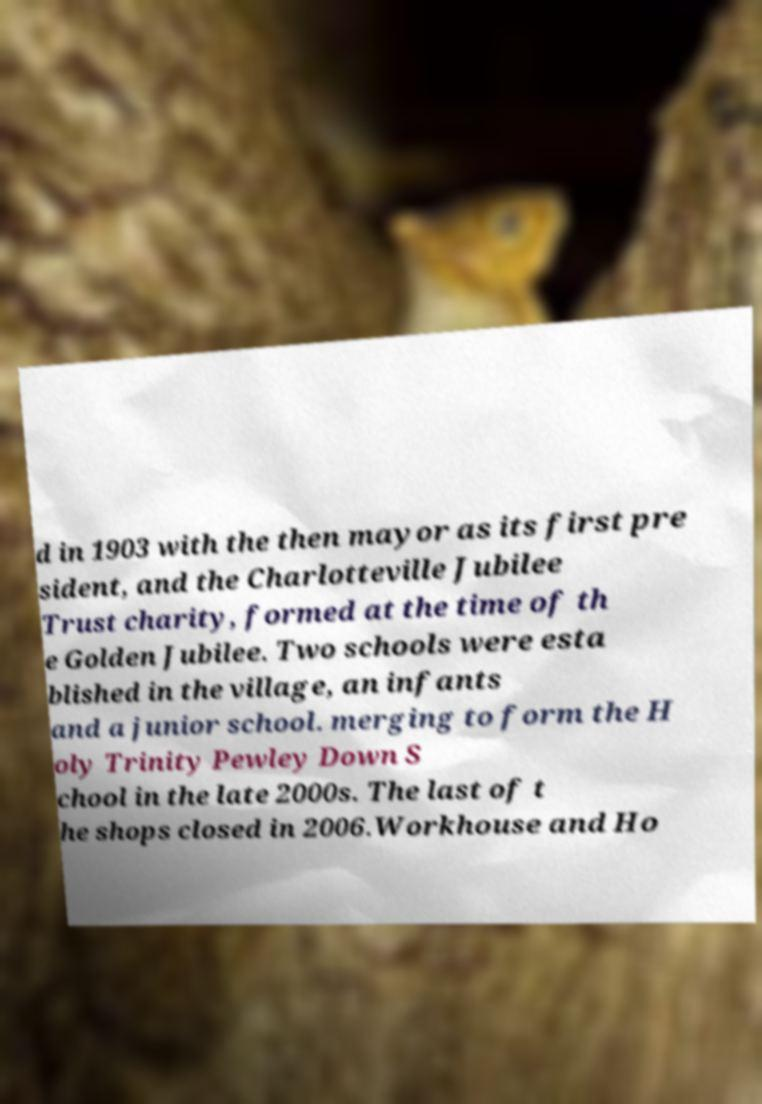Please identify and transcribe the text found in this image. d in 1903 with the then mayor as its first pre sident, and the Charlotteville Jubilee Trust charity, formed at the time of th e Golden Jubilee. Two schools were esta blished in the village, an infants and a junior school. merging to form the H oly Trinity Pewley Down S chool in the late 2000s. The last of t he shops closed in 2006.Workhouse and Ho 